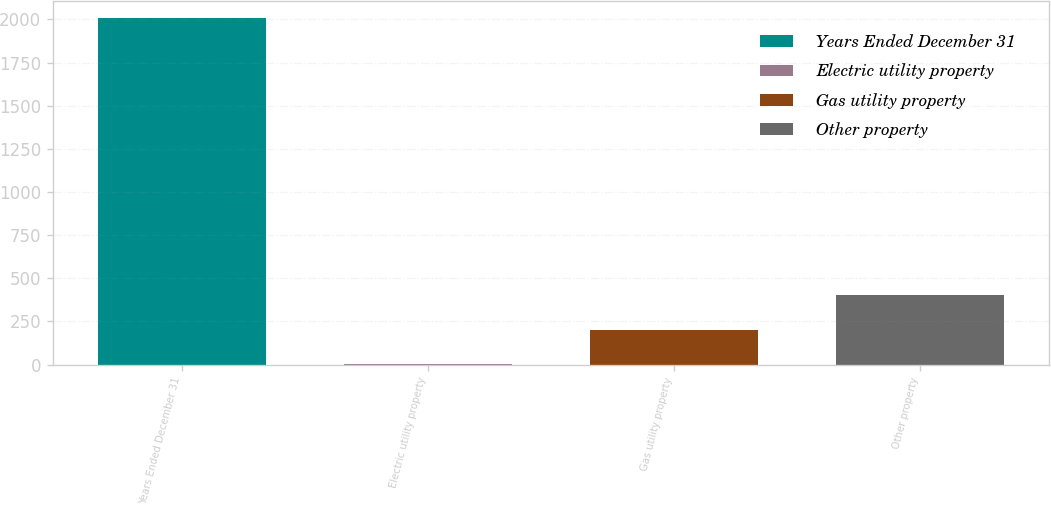<chart> <loc_0><loc_0><loc_500><loc_500><bar_chart><fcel>Years Ended December 31<fcel>Electric utility property<fcel>Gas utility property<fcel>Other property<nl><fcel>2007<fcel>3<fcel>203.4<fcel>403.8<nl></chart> 